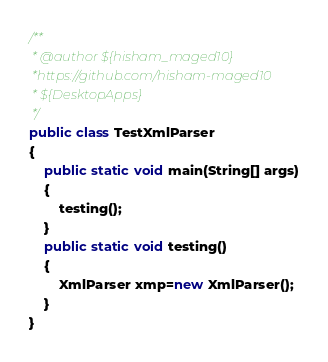<code> <loc_0><loc_0><loc_500><loc_500><_Java_>/**
 * @author ${hisham_maged10}
 *https://github.com/hisham-maged10
 * ${DesktopApps}
 */
public class TestXmlParser
{
	public static void main(String[] args)
	{
		testing();
	} 
	public static void testing()
	{
		XmlParser xmp=new XmlParser();
	}
}</code> 